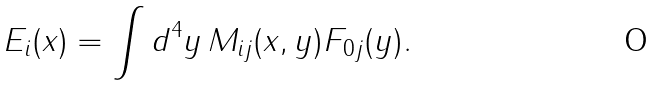Convert formula to latex. <formula><loc_0><loc_0><loc_500><loc_500>E _ { i } ( x ) = \int d ^ { 4 } y \, M _ { i j } ( x , y ) F _ { 0 j } ( y ) .</formula> 